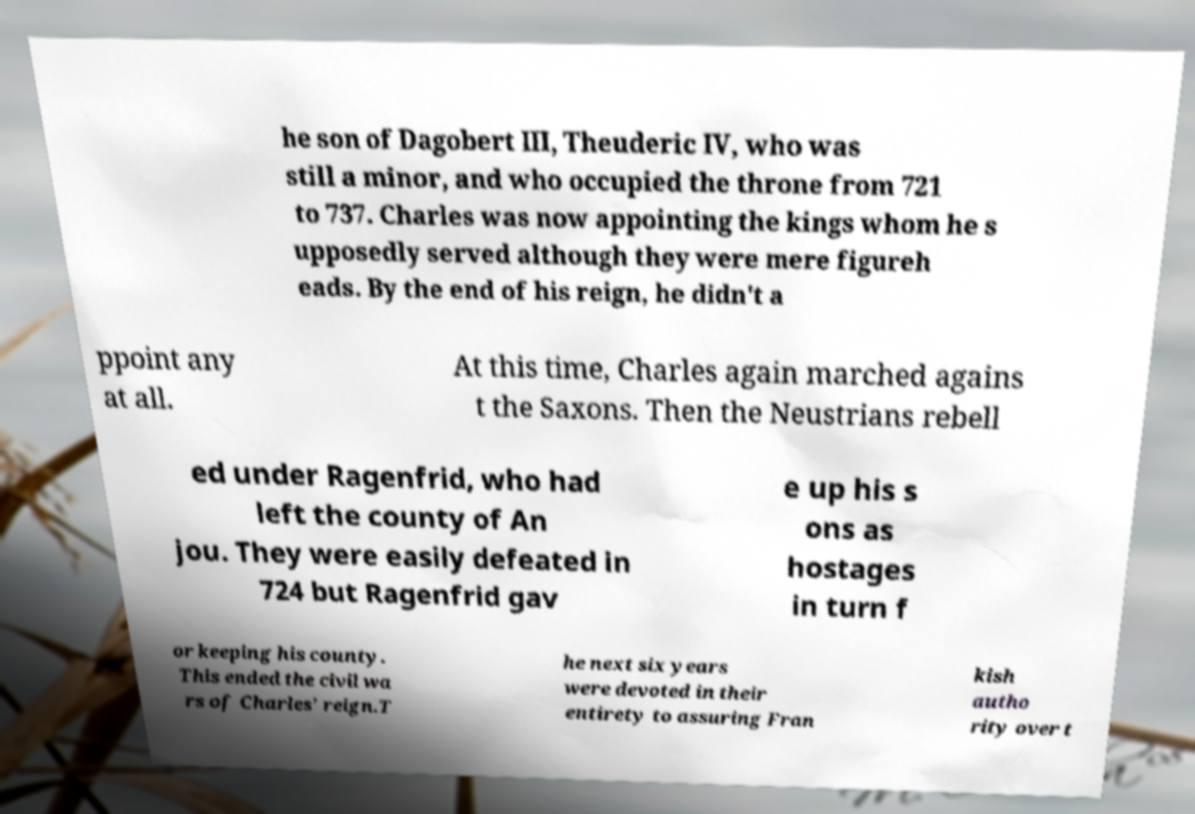Could you extract and type out the text from this image? he son of Dagobert III, Theuderic IV, who was still a minor, and who occupied the throne from 721 to 737. Charles was now appointing the kings whom he s upposedly served although they were mere figureh eads. By the end of his reign, he didn't a ppoint any at all. At this time, Charles again marched agains t the Saxons. Then the Neustrians rebell ed under Ragenfrid, who had left the county of An jou. They were easily defeated in 724 but Ragenfrid gav e up his s ons as hostages in turn f or keeping his county. This ended the civil wa rs of Charles' reign.T he next six years were devoted in their entirety to assuring Fran kish autho rity over t 